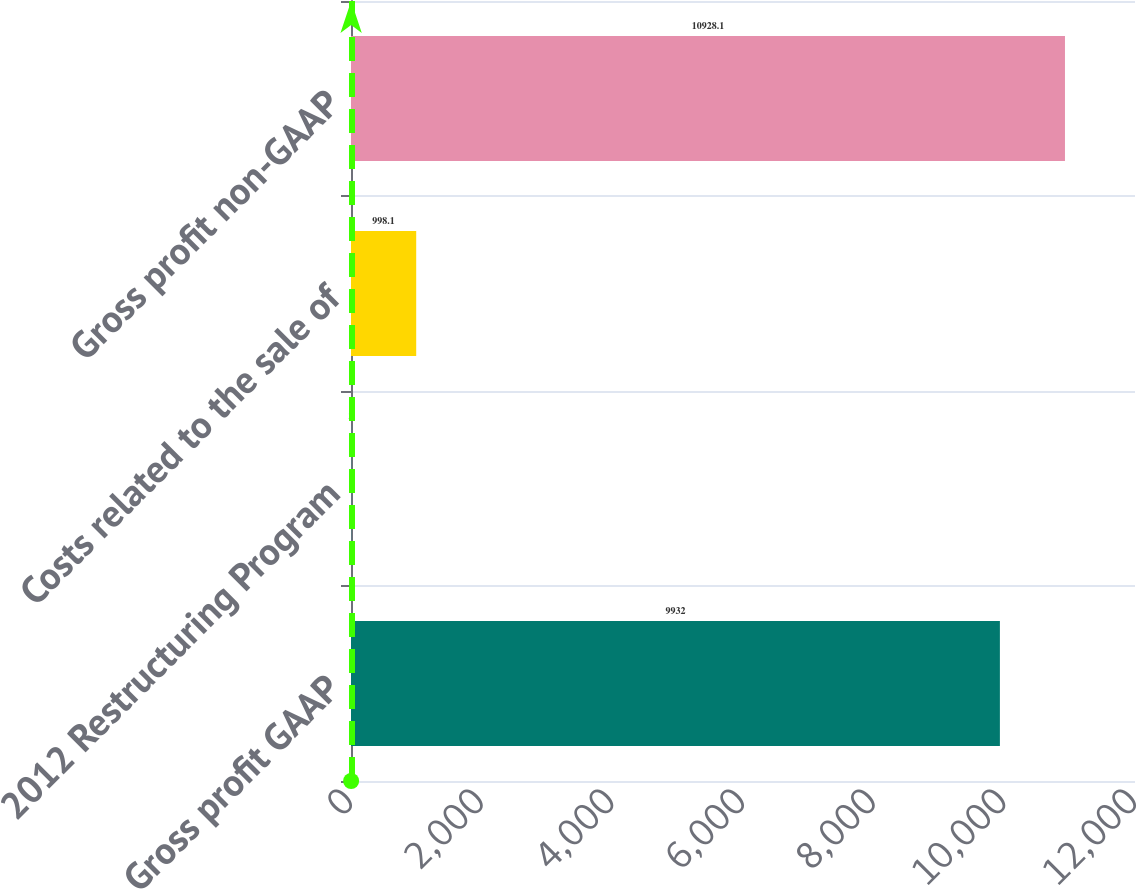Convert chart to OTSL. <chart><loc_0><loc_0><loc_500><loc_500><bar_chart><fcel>Gross profit GAAP<fcel>2012 Restructuring Program<fcel>Costs related to the sale of<fcel>Gross profit non-GAAP<nl><fcel>9932<fcel>2<fcel>998.1<fcel>10928.1<nl></chart> 